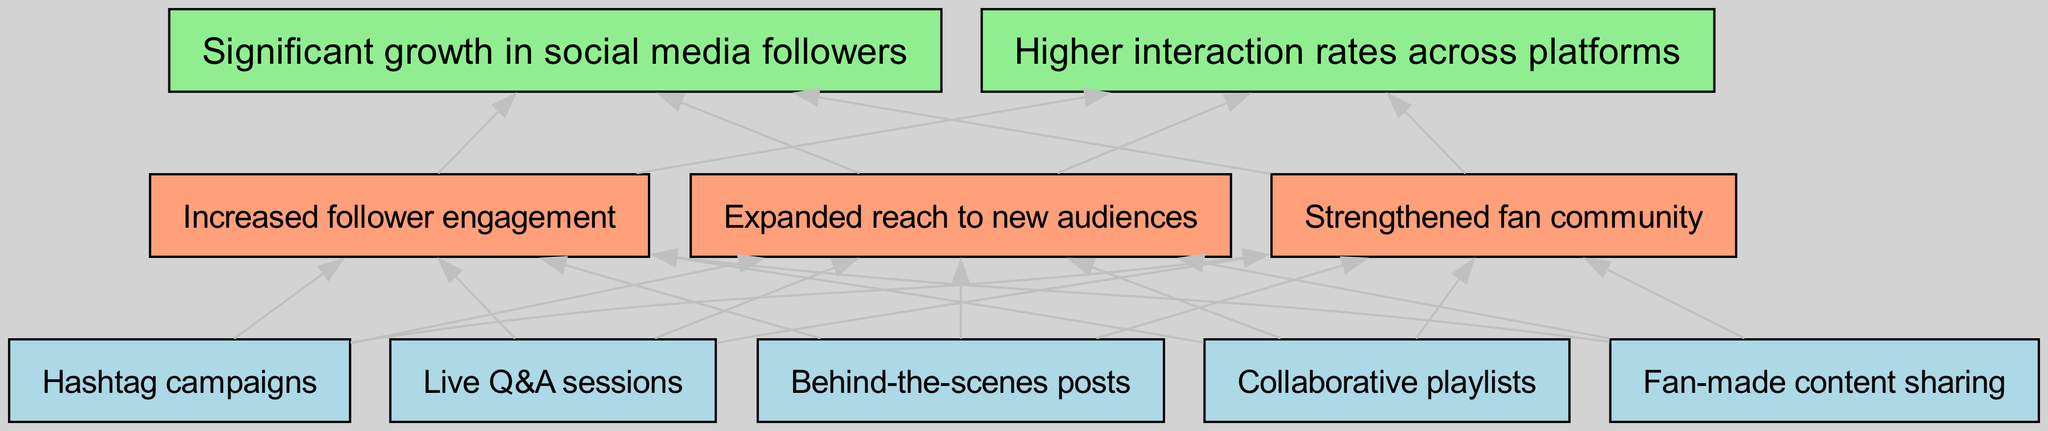What are the elements of the bottom level? The bottom level contains five nodes: Fan-made content sharing, Hashtag campaigns, Live Q&A sessions, Behind-the-scenes posts, and Collaborative playlists.
Answer: Five How many nodes are in the top level? The top level has two nodes: Significant growth in social media followers and Higher interaction rates across platforms.
Answer: Two What connects the "Hashtag campaigns" node? The "Hashtag campaigns" node is connected to all three middle-level nodes: Increased follower engagement, Expanded reach to new audiences, and Strengthened fan community.
Answer: Three Which middle-level node is directly linked to the "Collaborative playlists"? The "Collaborative playlists" node connects to all three middle-level nodes in the diagram, specifically to Increased follower engagement.
Answer: Increased follower engagement What is the main effect shown in the top level? The main effects shown in the top level of the diagram are significant growth in social media followers and higher interaction rates across platforms.
Answer: Significant growth in social media followers, Higher interaction rates across platforms How does "Fan-made content sharing" contribute to the overall goal? "Fan-made content sharing" leads to increased follower engagement, which is a vital step toward achieving the significant growth in social media followers depicted in the top level.
Answer: Increased follower engagement If there are five nodes at the bottom level, how many edges connect them to the middle level? From each of the five bottom-level nodes, there are three edges connecting them to the middle level. Thus, 5 multiplied by 3 gives a total of 15 edges.
Answer: Fifteen What does the bottom level primarily focus on? The bottom level focuses on various interactive and community-building activities such as Fan-made content sharing, Hashtag campaigns, Live Q&A sessions, Behind-the-scenes posts, and Collaborative playlists.
Answer: Engagement activities How is the community strengthened according to the diagram? The community is strengthened through increased follower engagement and expanded reach to new audiences, which are results from activities like Live Q&A sessions and Hashtag campaigns in the bottom level.
Answer: Increased follower engagement and expanded reach to new audiences 